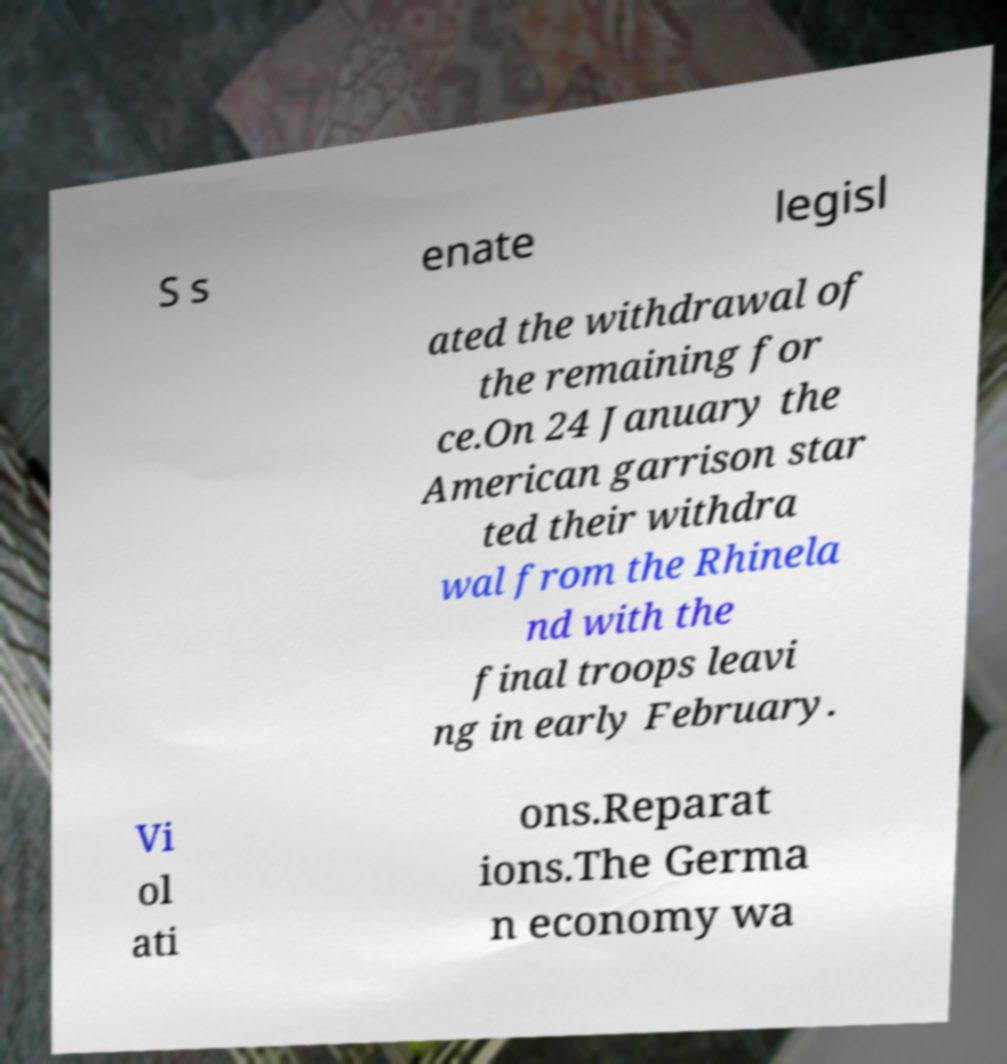For documentation purposes, I need the text within this image transcribed. Could you provide that? S s enate legisl ated the withdrawal of the remaining for ce.On 24 January the American garrison star ted their withdra wal from the Rhinela nd with the final troops leavi ng in early February. Vi ol ati ons.Reparat ions.The Germa n economy wa 